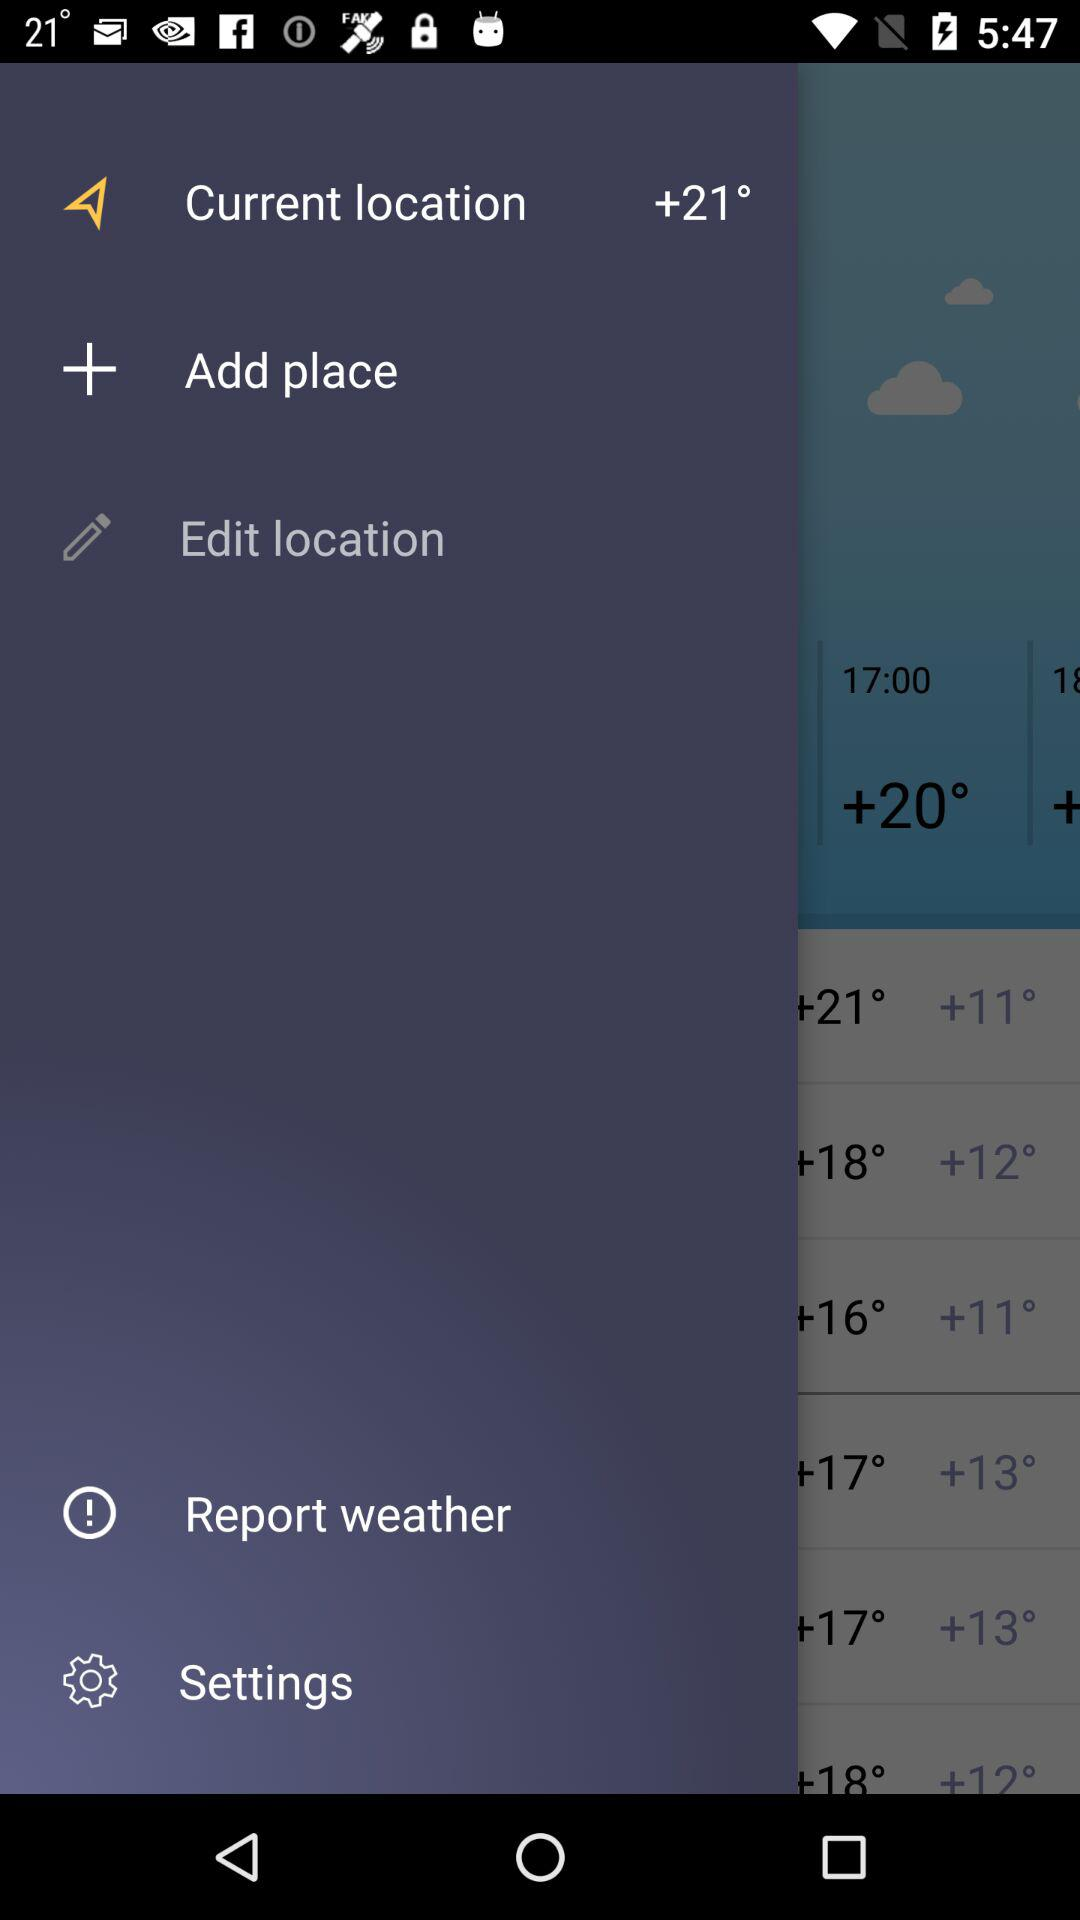How many more degrees is the temperature of the location with the +18° text than the location with the +11° text?
Answer the question using a single word or phrase. 7 